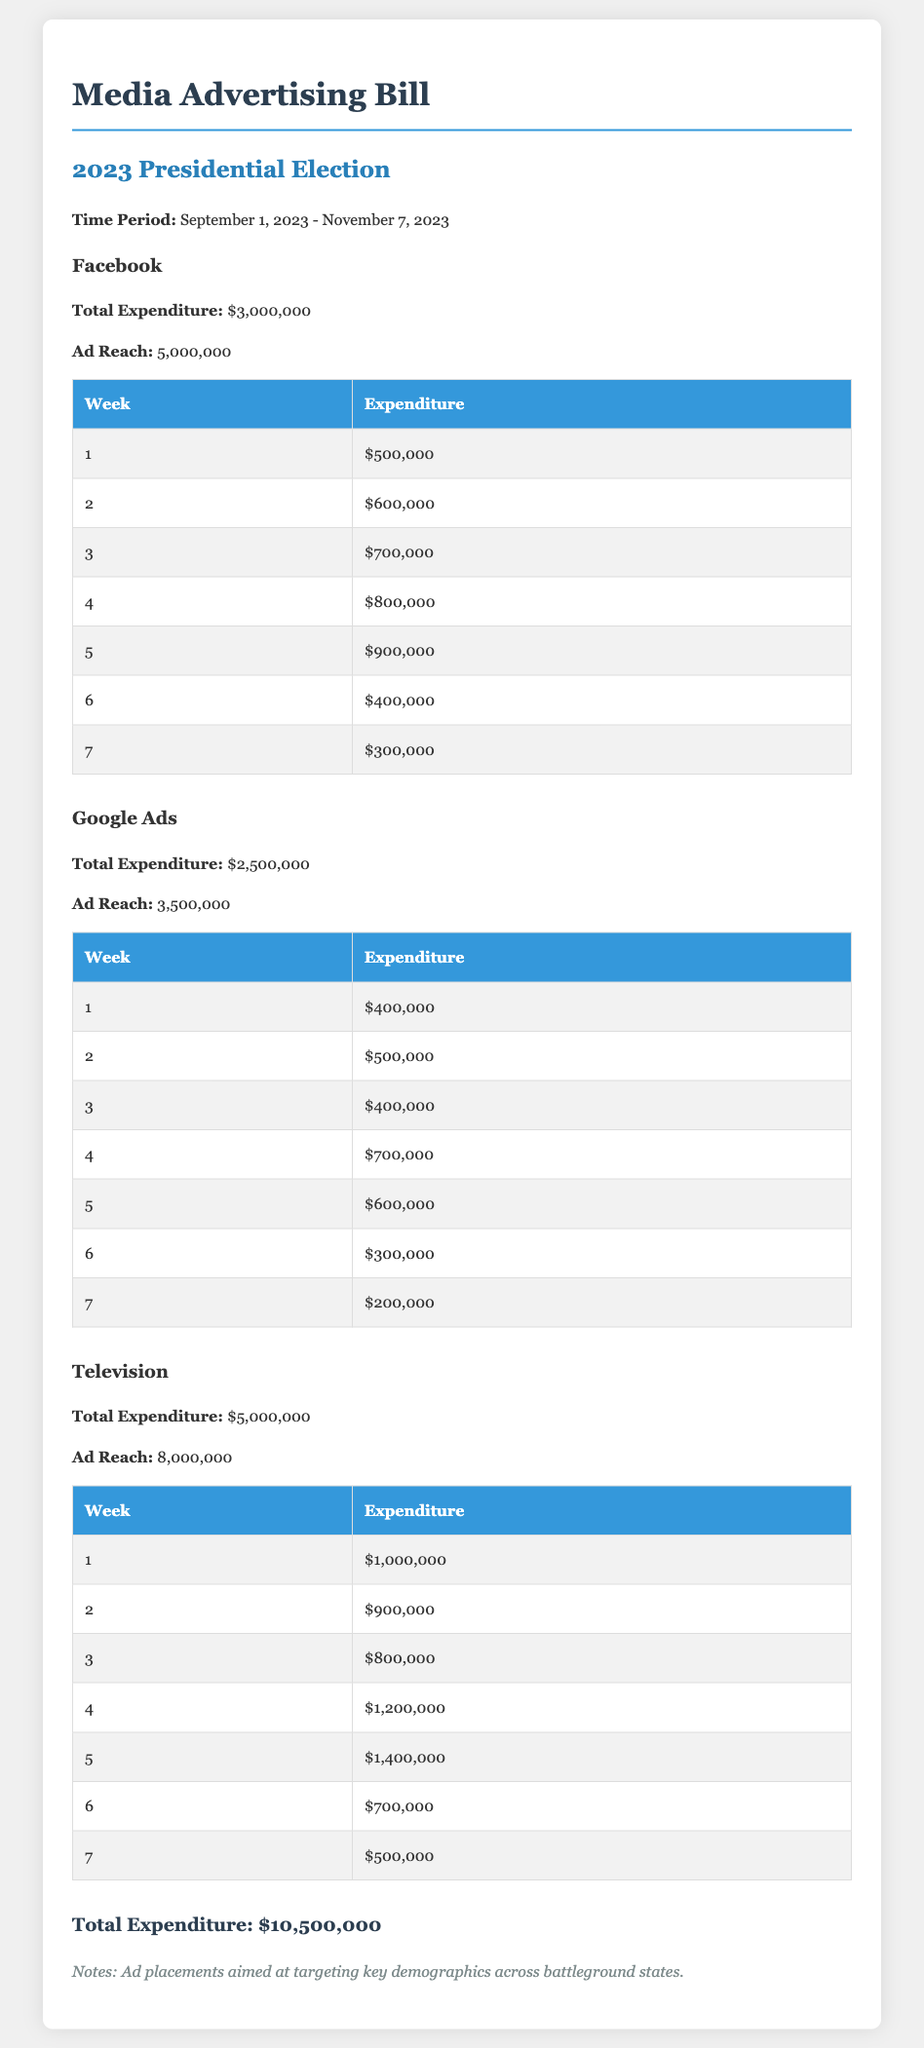what is the total expenditure on Facebook? The total expenditure on Facebook is explicitly provided in the document as $3,000,000.
Answer: $3,000,000 how many weeks does the advertising cover? The advertising period is outlined as lasting from September 1, 2023, to November 7, 2023, which encompasses 7 weeks.
Answer: 7 weeks what is the ad reach of Google Ads? The document specifies that the ad reach for Google Ads is 3,500,000.
Answer: 3,500,000 which platform had the highest total expenditure? By comparing expenditures, the highest total expenditure is recorded for Television at $5,000,000.
Answer: Television what is the total ad reach across all platforms? The total ad reach can be calculated by summing the ad reaches for all platforms: 5,000,000 + 3,500,000 + 8,000,000 = 16,500,000.
Answer: 16,500,000 what was the expenditure in week 4 on Television? The expenditure for week 4 on Television is specified as $1,200,000.
Answer: $1,200,000 how much was spent on Google Ads in the second week? The document states that the expenditure on Google Ads in the second week was $500,000.
Answer: $500,000 what is the total expenditure across all platforms? The total expenditure is provided in the document as $10,500,000, which is the sum of all individual platform expenditures.
Answer: $10,500,000 